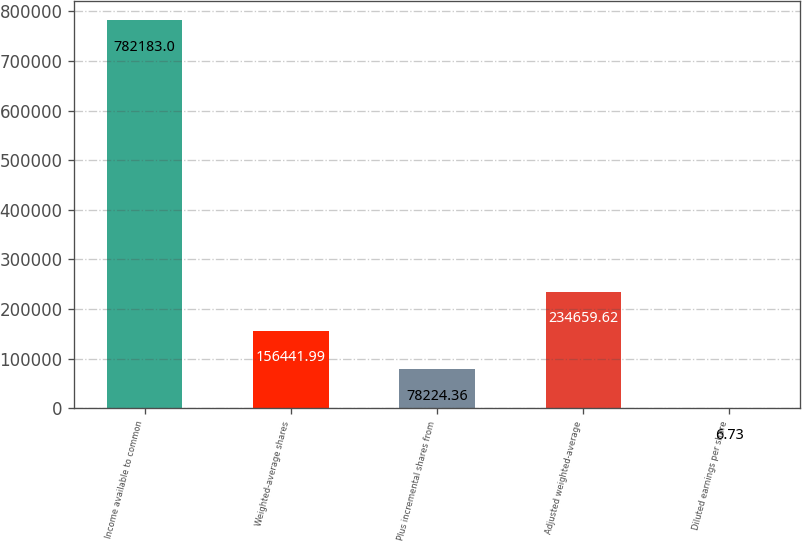Convert chart. <chart><loc_0><loc_0><loc_500><loc_500><bar_chart><fcel>Income available to common<fcel>Weighted-average shares<fcel>Plus incremental shares from<fcel>Adjusted weighted-average<fcel>Diluted earnings per share<nl><fcel>782183<fcel>156442<fcel>78224.4<fcel>234660<fcel>6.73<nl></chart> 